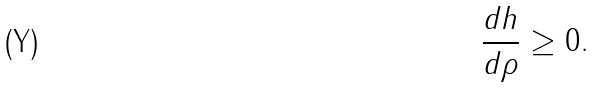Convert formula to latex. <formula><loc_0><loc_0><loc_500><loc_500>\frac { d h } { d \rho } \geq 0 .</formula> 